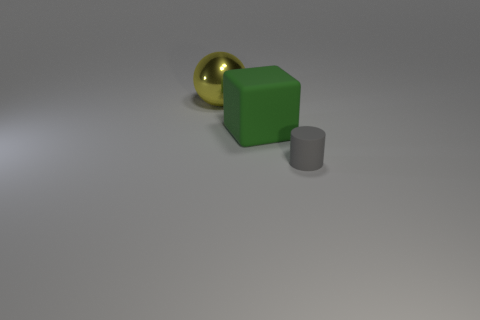There is a large yellow metallic sphere; are there any large metal things to the right of it?
Your answer should be compact. No. Is there a gray thing that has the same material as the yellow ball?
Provide a short and direct response. No. The cylinder has what color?
Give a very brief answer. Gray. There is a large thing that is in front of the metal ball; is it the same shape as the big yellow thing?
Ensure brevity in your answer.  No. What is the shape of the large object on the right side of the thing that is behind the rubber object to the left of the matte cylinder?
Make the answer very short. Cube. What material is the large yellow thing that is to the left of the large matte cube?
Give a very brief answer. Metal. There is a rubber cube that is the same size as the yellow sphere; what color is it?
Ensure brevity in your answer.  Green. How many other things are there of the same shape as the large green rubber thing?
Keep it short and to the point. 0. Do the rubber cylinder and the yellow thing have the same size?
Give a very brief answer. No. Are there more tiny gray cylinders that are in front of the large yellow thing than matte things that are on the right side of the small cylinder?
Provide a short and direct response. Yes. 